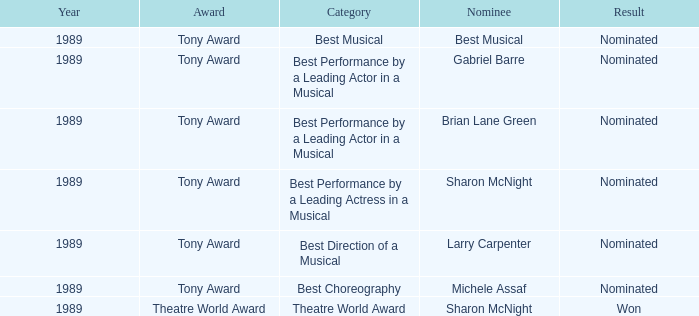What was the nominee of best musical Best Musical. 